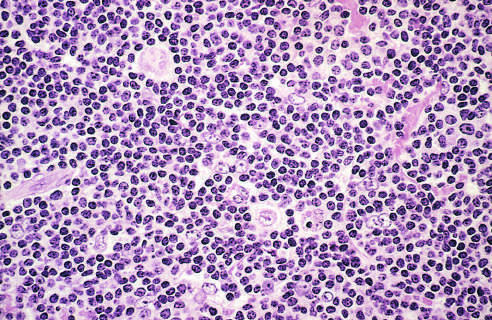do small vegetations surround scattered, large, pale-staining lymphocytic and histiocytic variants popcorn cells?
Answer the question using a single word or phrase. No 